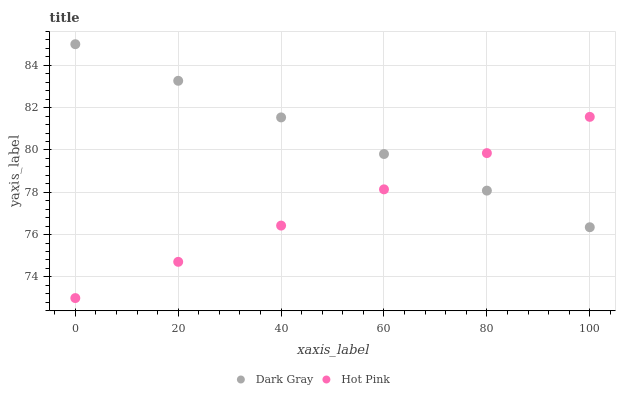Does Hot Pink have the minimum area under the curve?
Answer yes or no. Yes. Does Dark Gray have the maximum area under the curve?
Answer yes or no. Yes. Does Hot Pink have the maximum area under the curve?
Answer yes or no. No. Is Hot Pink the smoothest?
Answer yes or no. Yes. Is Dark Gray the roughest?
Answer yes or no. Yes. Is Hot Pink the roughest?
Answer yes or no. No. Does Hot Pink have the lowest value?
Answer yes or no. Yes. Does Dark Gray have the highest value?
Answer yes or no. Yes. Does Hot Pink have the highest value?
Answer yes or no. No. Does Dark Gray intersect Hot Pink?
Answer yes or no. Yes. Is Dark Gray less than Hot Pink?
Answer yes or no. No. Is Dark Gray greater than Hot Pink?
Answer yes or no. No. 